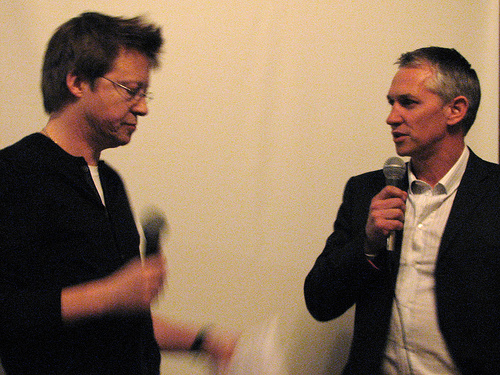<image>
Is the man to the left of the man? No. The man is not to the left of the man. From this viewpoint, they have a different horizontal relationship. 